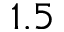<formula> <loc_0><loc_0><loc_500><loc_500>1 . 5</formula> 